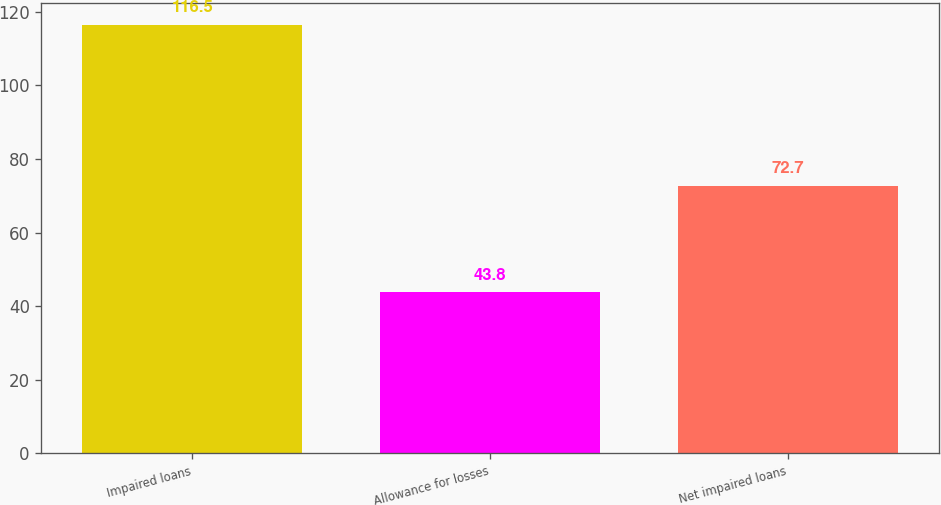Convert chart to OTSL. <chart><loc_0><loc_0><loc_500><loc_500><bar_chart><fcel>Impaired loans<fcel>Allowance for losses<fcel>Net impaired loans<nl><fcel>116.5<fcel>43.8<fcel>72.7<nl></chart> 